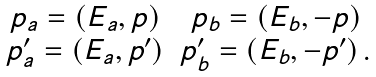<formula> <loc_0><loc_0><loc_500><loc_500>\begin{array} { c c } { { p _ { a } = \left ( E _ { a } , { p } \right ) } } & { { p _ { b } = \left ( E _ { b } , - { p } \right ) } } \\ { { p _ { a } ^ { \prime } = \left ( E _ { a } , { p } ^ { \prime } \right ) } } & { { p _ { b } ^ { \prime } = \left ( E _ { b } , - { p } ^ { \prime } \right ) . } } \end{array}</formula> 